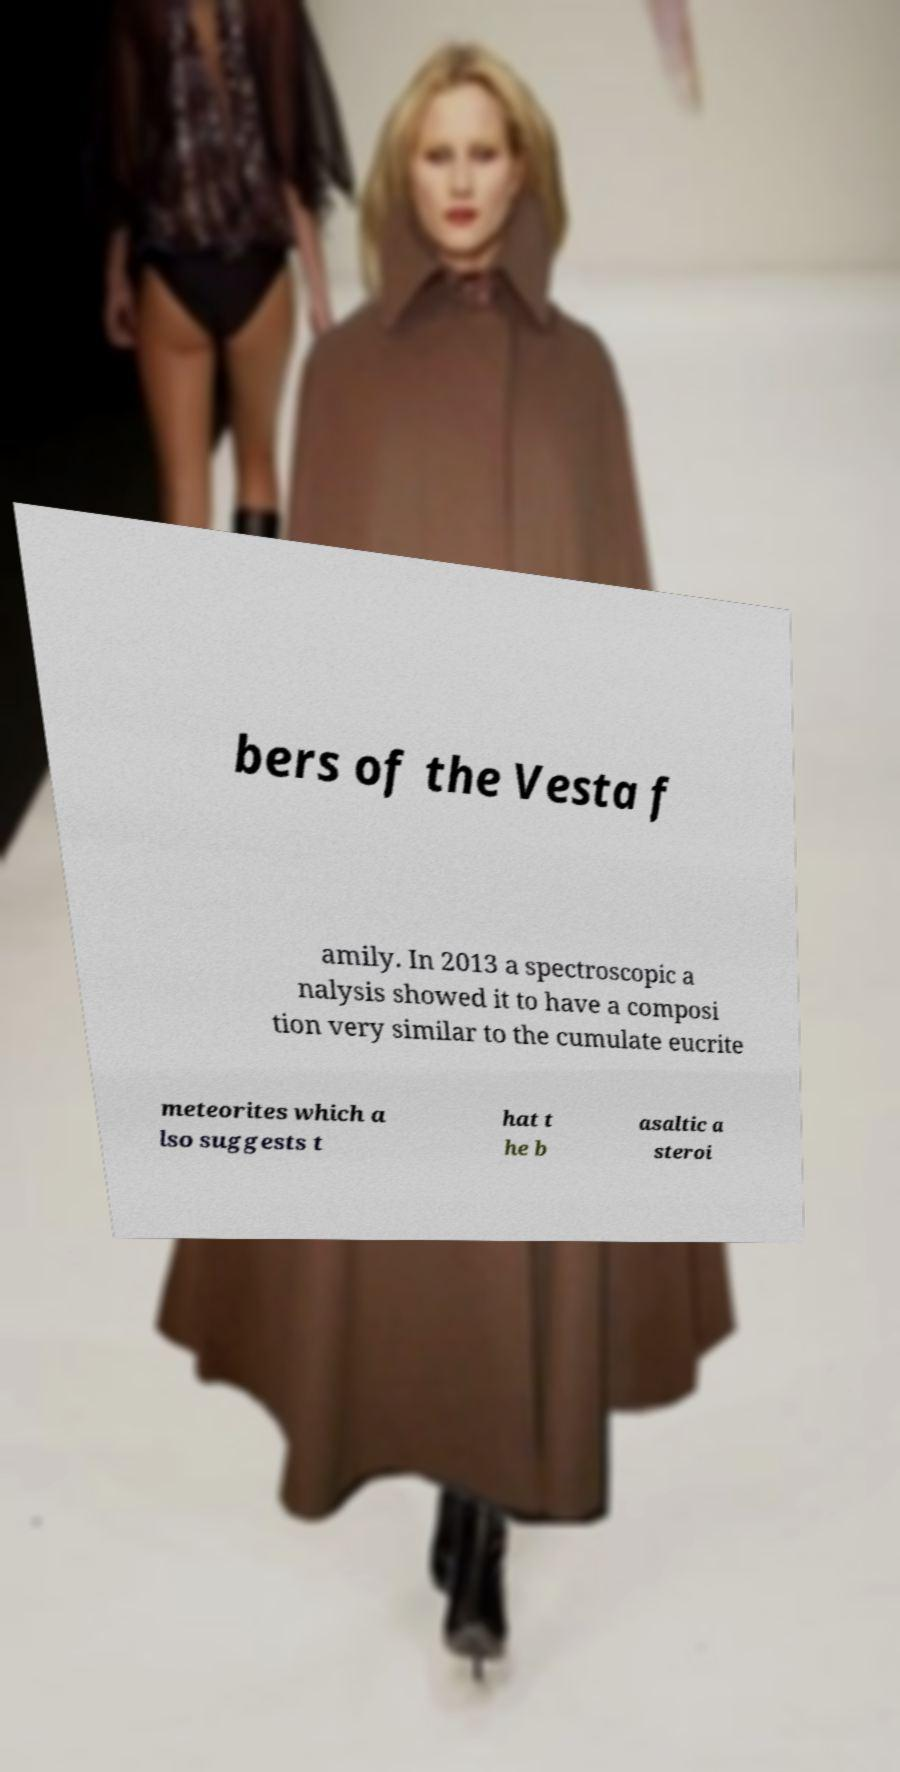Please identify and transcribe the text found in this image. bers of the Vesta f amily. In 2013 a spectroscopic a nalysis showed it to have a composi tion very similar to the cumulate eucrite meteorites which a lso suggests t hat t he b asaltic a steroi 